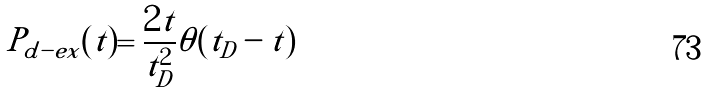Convert formula to latex. <formula><loc_0><loc_0><loc_500><loc_500>P _ { d - e x } ( t ) = \frac { 2 t } { t _ { D } ^ { 2 } } \theta ( t _ { D } - t )</formula> 